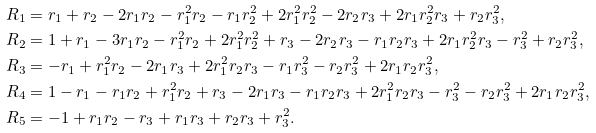Convert formula to latex. <formula><loc_0><loc_0><loc_500><loc_500>R _ { 1 } & = r _ { 1 } + r _ { 2 } - 2 r _ { 1 } r _ { 2 } - r _ { 1 } ^ { 2 } r _ { 2 } - r _ { 1 } r _ { 2 } ^ { 2 } + 2 r _ { 1 } ^ { 2 } r _ { 2 } ^ { 2 } - 2 r _ { 2 } r _ { 3 } + 2 r _ { 1 } r _ { 2 } ^ { 2 } r _ { 3 } + r _ { 2 } r _ { 3 } ^ { 2 } , \\ R _ { 2 } & = 1 + r _ { 1 } - 3 r _ { 1 } r _ { 2 } - r _ { 1 } ^ { 2 } r _ { 2 } + 2 r _ { 1 } ^ { 2 } r _ { 2 } ^ { 2 } + r _ { 3 } - 2 r _ { 2 } r _ { 3 } - r _ { 1 } r _ { 2 } r _ { 3 } + 2 r _ { 1 } r _ { 2 } ^ { 2 } r _ { 3 } - r _ { 3 } ^ { 2 } + r _ { 2 } r _ { 3 } ^ { 2 } , \\ R _ { 3 } & = - r _ { 1 } + r _ { 1 } ^ { 2 } r _ { 2 } - 2 r _ { 1 } r _ { 3 } + 2 r _ { 1 } ^ { 2 } r _ { 2 } r _ { 3 } - r _ { 1 } r _ { 3 } ^ { 2 } - r _ { 2 } r _ { 3 } ^ { 2 } + 2 r _ { 1 } r _ { 2 } r _ { 3 } ^ { 2 } , \\ R _ { 4 } & = 1 - r _ { 1 } - r _ { 1 } r _ { 2 } + r _ { 1 } ^ { 2 } r _ { 2 } + r _ { 3 } - 2 r _ { 1 } r _ { 3 } - r _ { 1 } r _ { 2 } r _ { 3 } + 2 r _ { 1 } ^ { 2 } r _ { 2 } r _ { 3 } - r _ { 3 } ^ { 2 } - r _ { 2 } r _ { 3 } ^ { 2 } + 2 r _ { 1 } r _ { 2 } r _ { 3 } ^ { 2 } , \\ R _ { 5 } & = - 1 + r _ { 1 } r _ { 2 } - r _ { 3 } + r _ { 1 } r _ { 3 } + r _ { 2 } r _ { 3 } + r _ { 3 } ^ { 2 } .</formula> 